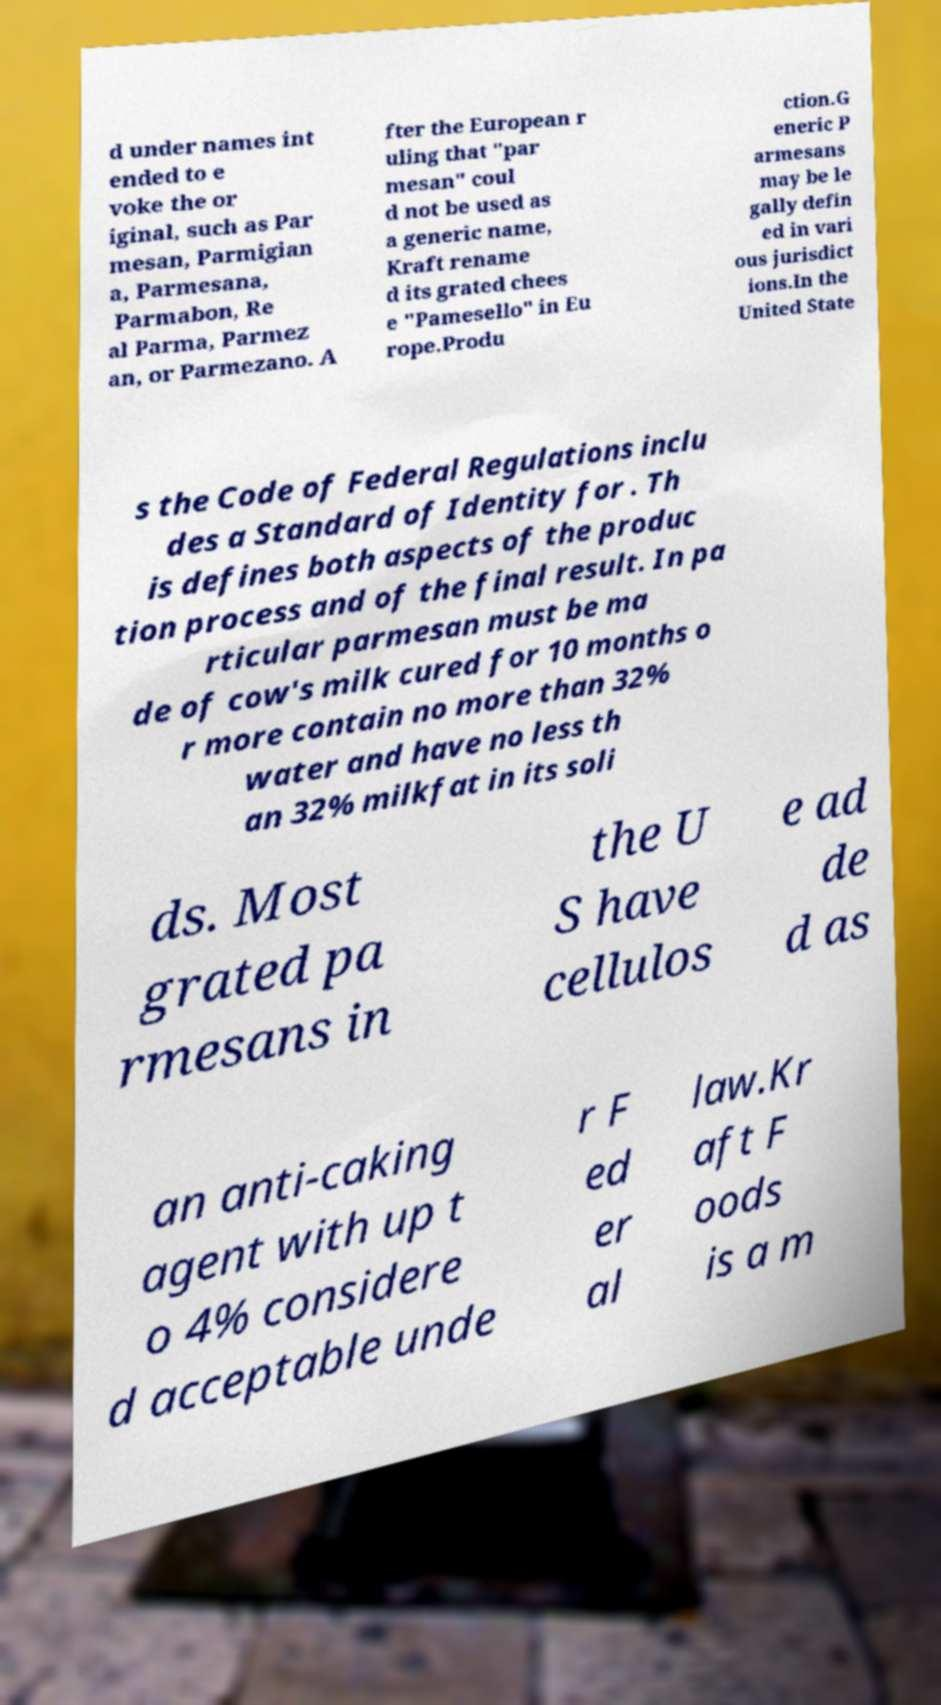Can you accurately transcribe the text from the provided image for me? d under names int ended to e voke the or iginal, such as Par mesan, Parmigian a, Parmesana, Parmabon, Re al Parma, Parmez an, or Parmezano. A fter the European r uling that "par mesan" coul d not be used as a generic name, Kraft rename d its grated chees e "Pamesello" in Eu rope.Produ ction.G eneric P armesans may be le gally defin ed in vari ous jurisdict ions.In the United State s the Code of Federal Regulations inclu des a Standard of Identity for . Th is defines both aspects of the produc tion process and of the final result. In pa rticular parmesan must be ma de of cow's milk cured for 10 months o r more contain no more than 32% water and have no less th an 32% milkfat in its soli ds. Most grated pa rmesans in the U S have cellulos e ad de d as an anti-caking agent with up t o 4% considere d acceptable unde r F ed er al law.Kr aft F oods is a m 